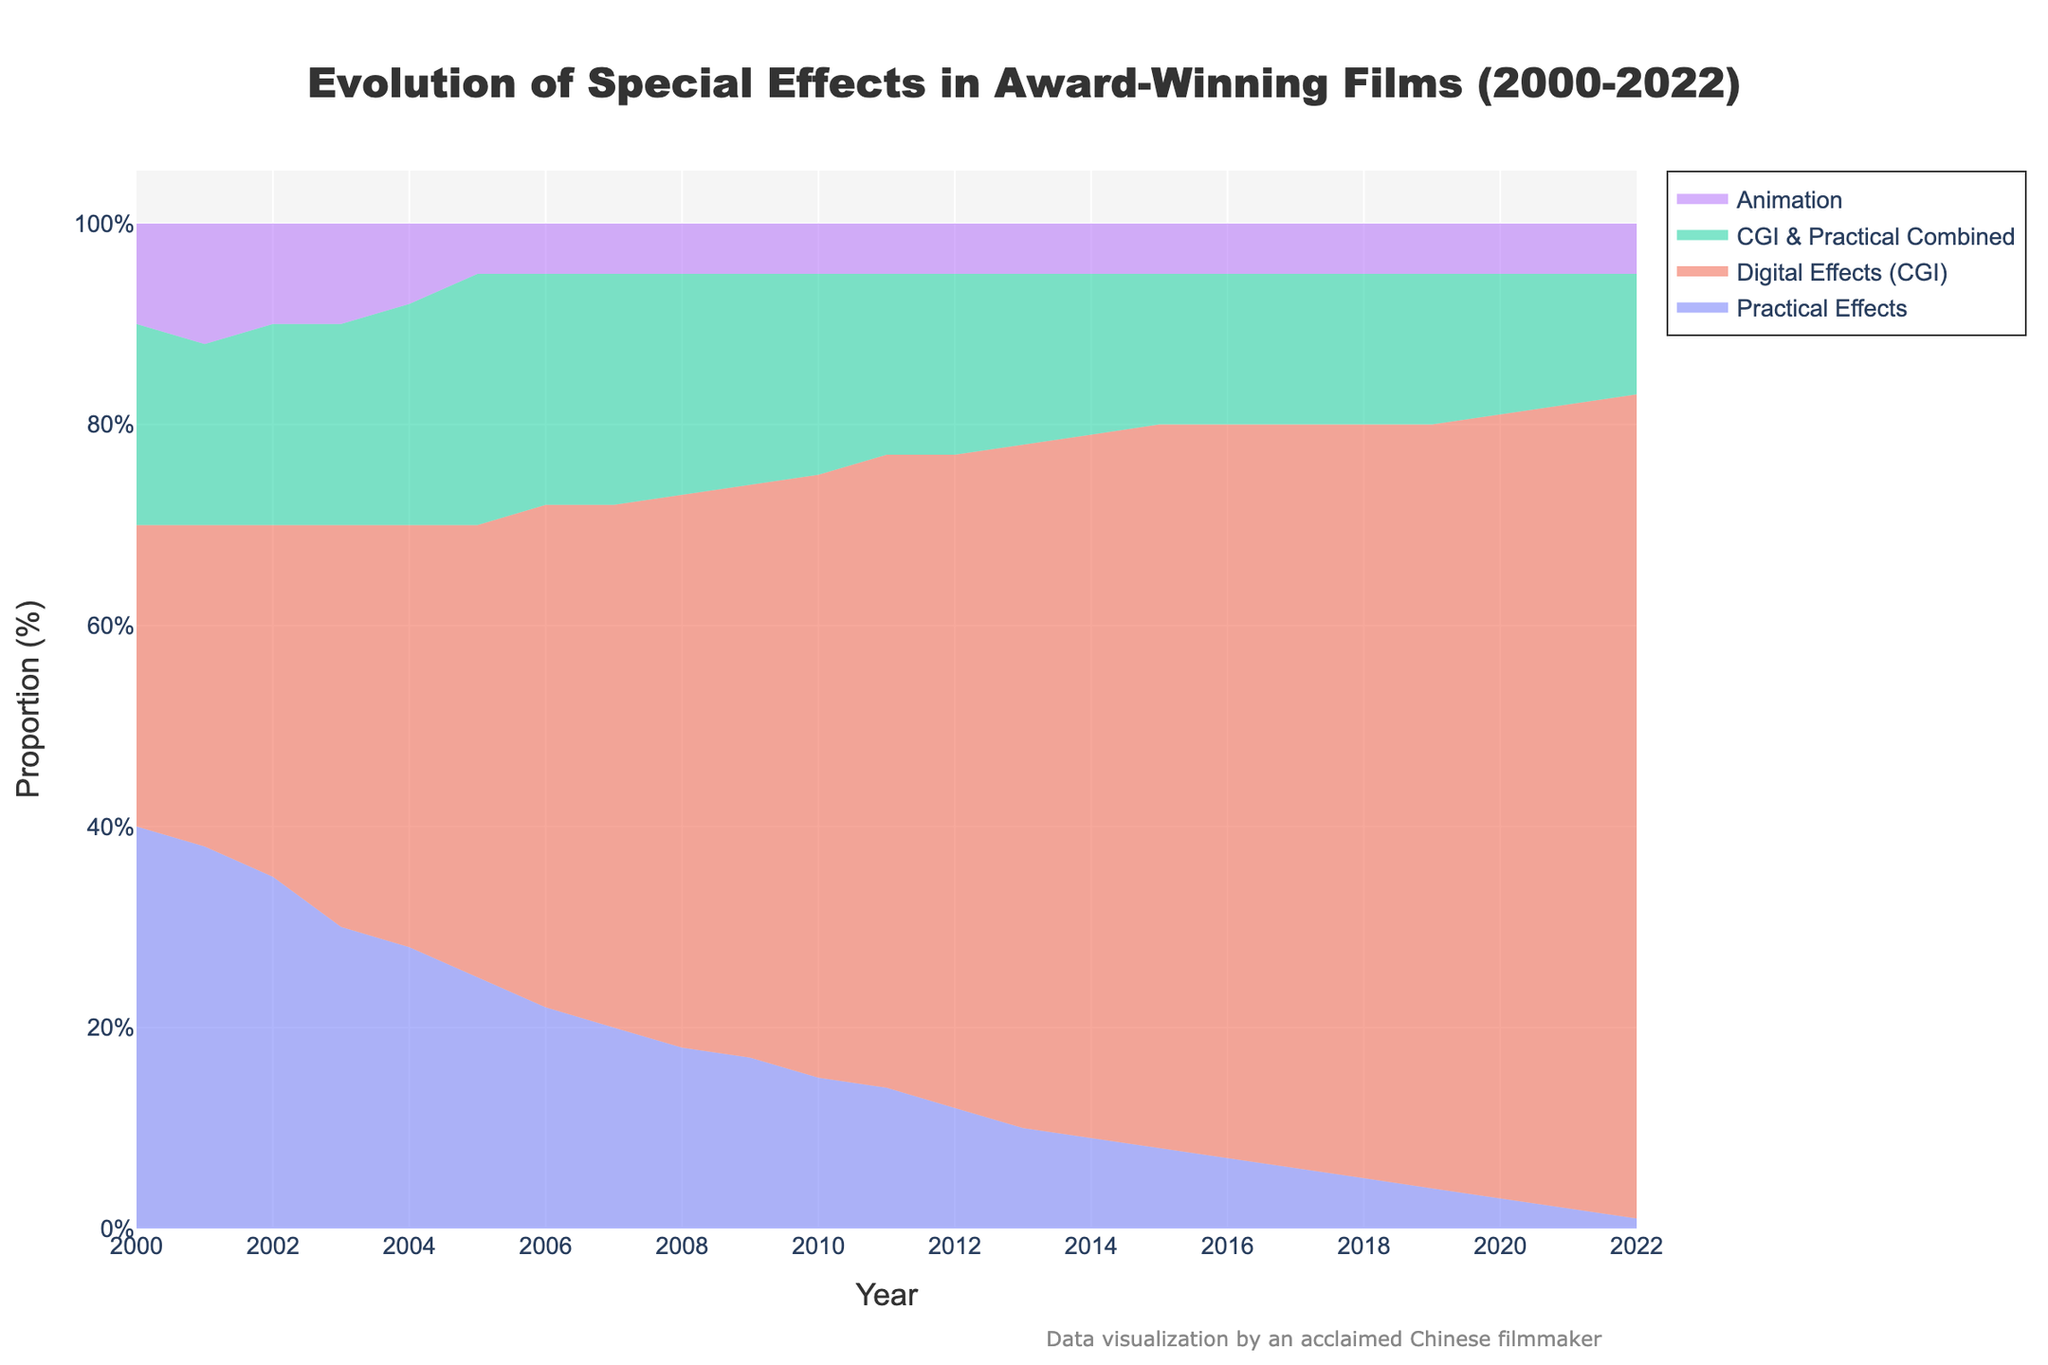Which year had the highest proportion of digital effects (CGI)? Look for the tallest segment representing Digital Effects (CGI) in the figure and identify the corresponding year on the x-axis.
Answer: 2022 How did the proportion of practical effects change from 2000 to 2022? Find the segment corresponding to Practical Effects in both 2000 and 2022 on the stacked area chart and compare their heights.
Answer: Decreased Compare the proportion of animation effects in 2000 and 2022. Look at the height of the Animation segment in 2000 and in 2022 to see if it has remained the same, increased, or decreased.
Answer: Same Which year saw the combined highest use of CGI & Practical Combined and Animation techniques? Sum the heights of the segments for CGI & Practical Combined and Animation for each year, then find the year where this combined height is the greatest.
Answer: 2004 When did the combined usage of Practical Effects and Digital Effects (CGI) first become less than 50%? For each year, sum up the heights for Practical Effects and Digital Effects (CGI); identify the first year this sum drops below 50%.
Answer: 2011 What was the dominant special effects technique used in 2015? Find the tallest segment in the year 2015 on the stacked area chart to identify the dominant special effects technique.
Answer: Digital Effects (CGI) Did the proportion of CGI & Practical Combined ever show a significant change, and if so, when? Look for notable rises or falls in the CGI & Practical Combined segment over the years in the stacked area chart and identify the corresponding years.
Answer: 2004-2005 Which year had the smallest proportion of Practical Effects? Identify the shortest Practical Effects segment in the stacked area chart and find the corresponding year on the x-axis.
Answer: 2022 Which special effects technique showed a consistent increase over the years? Identify the segment that gradually increases in height each year from 2000 to 2022 in the chart.
Answer: Digital Effects (CGI) 